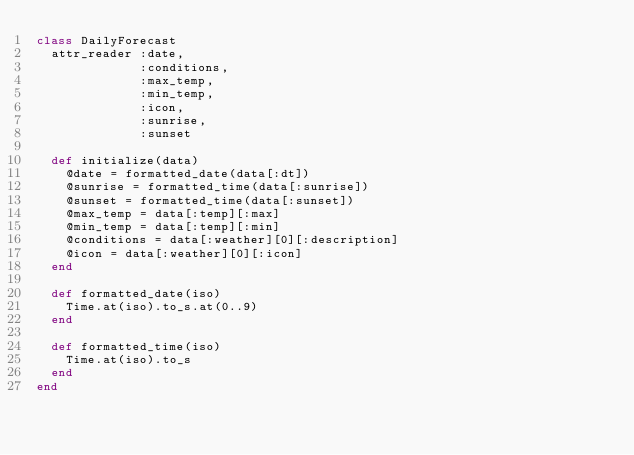Convert code to text. <code><loc_0><loc_0><loc_500><loc_500><_Ruby_>class DailyForecast
  attr_reader :date,
              :conditions,
              :max_temp,
              :min_temp,
              :icon,
              :sunrise,
              :sunset

  def initialize(data)
    @date = formatted_date(data[:dt])
    @sunrise = formatted_time(data[:sunrise])
    @sunset = formatted_time(data[:sunset])
    @max_temp = data[:temp][:max]
    @min_temp = data[:temp][:min]
    @conditions = data[:weather][0][:description]
    @icon = data[:weather][0][:icon]
  end

  def formatted_date(iso)
    Time.at(iso).to_s.at(0..9)
  end

  def formatted_time(iso)
    Time.at(iso).to_s
  end
end
</code> 